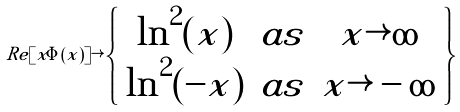Convert formula to latex. <formula><loc_0><loc_0><loc_500><loc_500>R e [ x \Phi ( x ) ] \rightarrow \left \{ \begin{array} { c c c } \ln ^ { 2 } ( x ) & a s & x \rightarrow \infty \\ \ln ^ { 2 } ( - x ) & a s & x \rightarrow - \infty \end{array} \right \}</formula> 